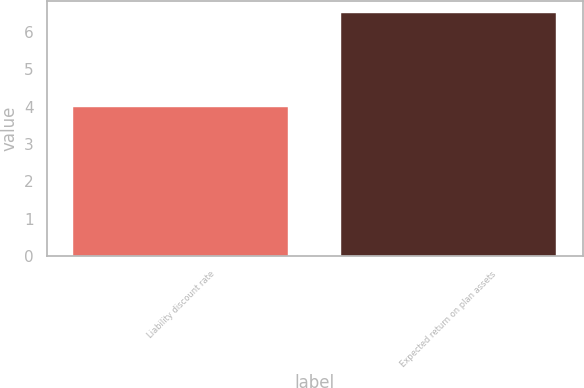<chart> <loc_0><loc_0><loc_500><loc_500><bar_chart><fcel>Liability discount rate<fcel>Expected return on plan assets<nl><fcel>4<fcel>6.5<nl></chart> 